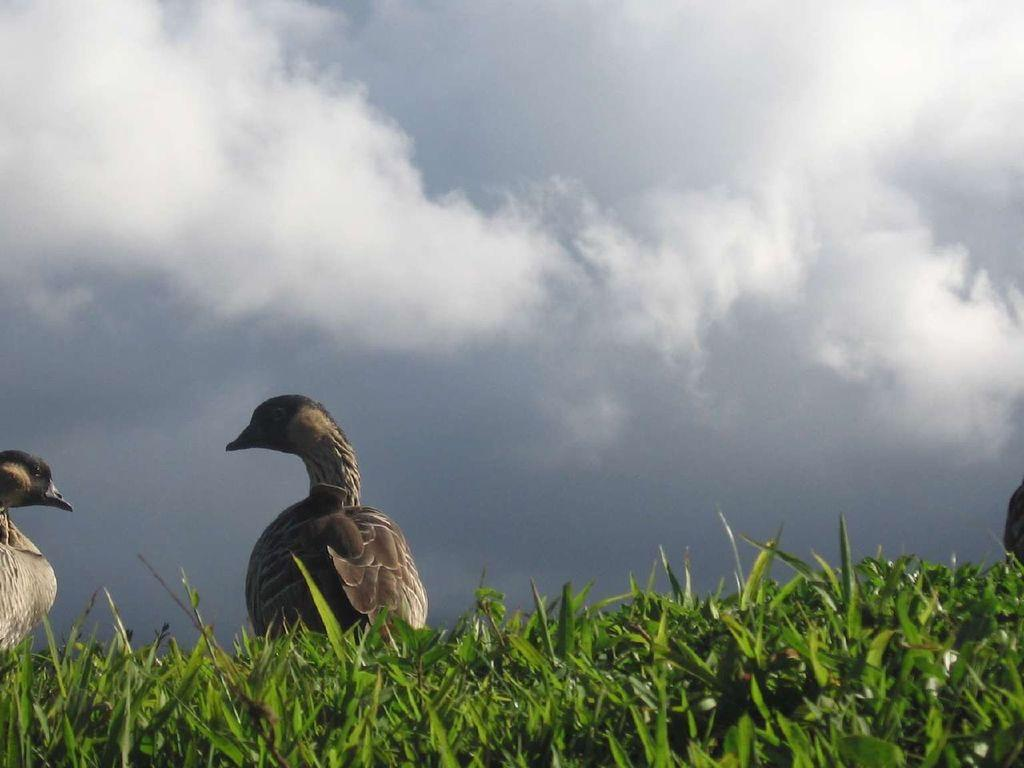What type of vegetation can be seen in the image? There is grass in the image. What animals are present in the image? There are two birds in the front of the image. What can be seen in the background of the image? There are clouds and the sky visible in the background of the image. Can you describe the black-colored object on the right side of the image? There is a black-colored object on the right side of the image, but its specific nature cannot be determined from the provided facts. What type of pie is being served on the skate in the image? There is no pie or skate present in the image. What type of box is being used to store the birds in the image? There is no box or indication of bird storage in the image. 